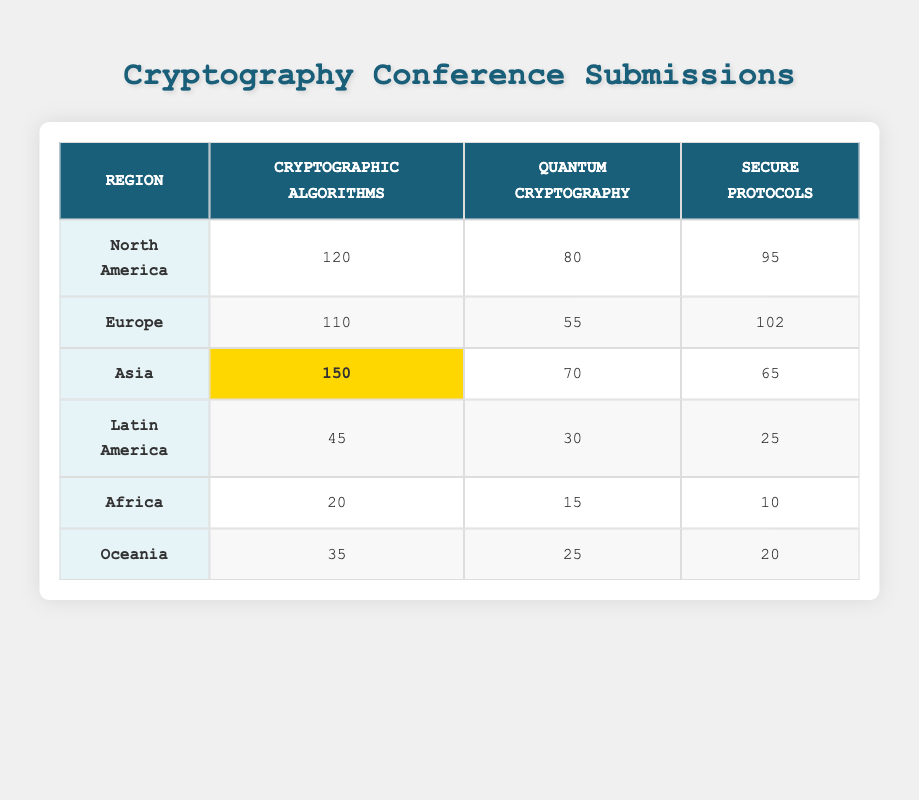What region has the highest number of submissions for Cryptographic Algorithms? The table shows that Asia has the highest number of submissions for Cryptographic Algorithms with a total of 150 submissions.
Answer: Asia How many submissions does Europe have for Secure Protocols? According to the table, Europe has 102 submissions for Secure Protocols.
Answer: 102 What is the difference in submissions between North America and Latin America in Quantum Cryptography? North America has 80 submissions and Latin America has 30 submissions for Quantum Cryptography. The difference is 80 - 30 = 50.
Answer: 50 What is the total number of submissions from Africa? From the table, Africa has submissions in three categories: 20 (Cryptographic Algorithms) + 15 (Quantum Cryptography) + 10 (Secure Protocols) = 45 in total.
Answer: 45 Does Oceania have more submissions in Cryptographic Algorithms than Africa? Oceania has 35 submissions in Cryptographic Algorithms, while Africa has 20. Since 35 is greater than 20, the statement is true.
Answer: Yes What is the average number of submissions for Quantum Cryptography across all regions? The number of submissions for Quantum Cryptography from each region is: North America (80), Europe (55), Asia (70), Latin America (30), Africa (15), Oceania (25). The total is 80 + 55 + 70 + 30 + 15 + 25 = 275. There are 6 regions, so the average is 275 / 6 = approximately 45.83.
Answer: 45.83 Which category of submissions received the least interest from Latin America? Latin America has 45 submissions in Cryptographic Algorithms, 30 in Quantum Cryptography, and 25 in Secure Protocols. Secure Protocols has the least with 25 submissions.
Answer: Secure Protocols What region has the highest total number of submissions among all categories? To find the region with the highest total, we sum the submissions in each category for each region. Asia has 150 + 70 + 65 = 285, while North America has 120 + 80 + 95 = 295, Europe has 110 + 55 + 102 = 267, Latin America has 45 + 30 + 25 = 100, Africa has 20 + 15 + 10 = 45, and Oceania has 35 + 25 + 20 = 80. North America has the highest total of 295 submissions.
Answer: North America How many more submissions does North America have in Secure Protocols than Oceania? North America has 95 submissions for Secure Protocols while Oceania has 20. The difference is 95 - 20 = 75 submissions.
Answer: 75 Is the total number of submissions from Europe higher than that from Asia? Europe has a total of 110 + 55 + 102 = 267 submissions, while Asia has 150 + 70 + 65 = 285 submissions. Since 267 is less than 285, the statement is false.
Answer: No 